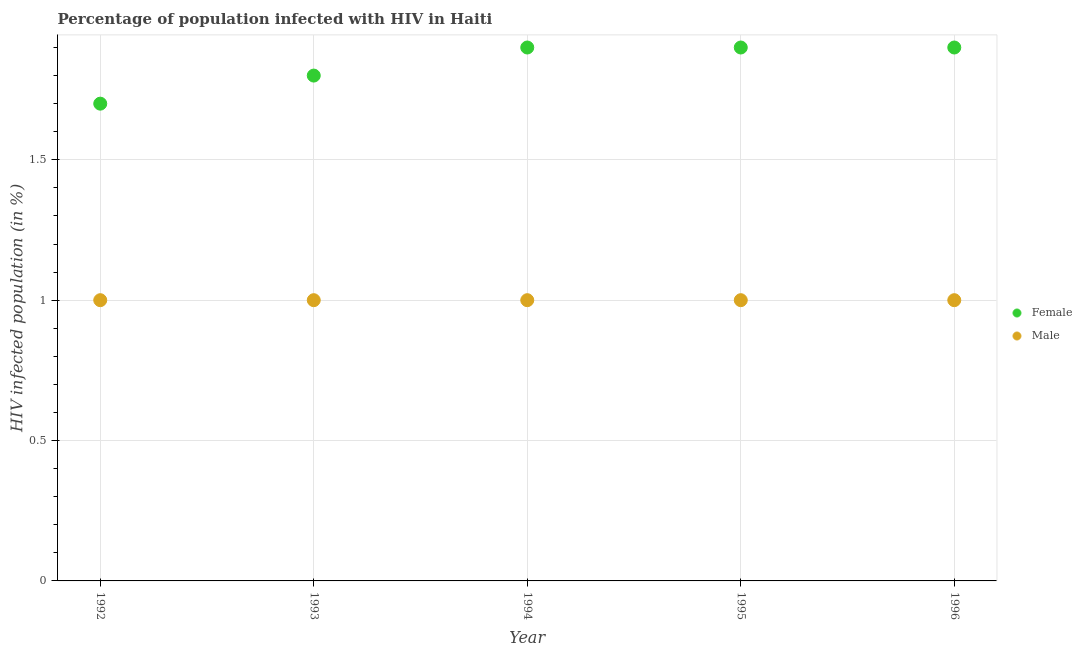What is the percentage of males who are infected with hiv in 1996?
Provide a succinct answer. 1. Across all years, what is the maximum percentage of females who are infected with hiv?
Offer a very short reply. 1.9. Across all years, what is the minimum percentage of males who are infected with hiv?
Your answer should be very brief. 1. In which year was the percentage of males who are infected with hiv minimum?
Ensure brevity in your answer.  1992. What is the total percentage of females who are infected with hiv in the graph?
Keep it short and to the point. 9.2. What is the difference between the percentage of females who are infected with hiv in 1992 and that in 1996?
Provide a succinct answer. -0.2. What is the difference between the percentage of females who are infected with hiv in 1995 and the percentage of males who are infected with hiv in 1992?
Ensure brevity in your answer.  0.9. In the year 1994, what is the difference between the percentage of males who are infected with hiv and percentage of females who are infected with hiv?
Provide a short and direct response. -0.9. In how many years, is the percentage of females who are infected with hiv greater than 1.2 %?
Keep it short and to the point. 5. What is the ratio of the percentage of males who are infected with hiv in 1993 to that in 1994?
Offer a terse response. 1. Is the percentage of males who are infected with hiv in 1994 less than that in 1995?
Keep it short and to the point. No. Is the difference between the percentage of males who are infected with hiv in 1994 and 1996 greater than the difference between the percentage of females who are infected with hiv in 1994 and 1996?
Provide a succinct answer. No. What is the difference between the highest and the lowest percentage of males who are infected with hiv?
Offer a very short reply. 0. In how many years, is the percentage of females who are infected with hiv greater than the average percentage of females who are infected with hiv taken over all years?
Ensure brevity in your answer.  3. Is the percentage of females who are infected with hiv strictly greater than the percentage of males who are infected with hiv over the years?
Provide a short and direct response. Yes. How many years are there in the graph?
Make the answer very short. 5. What is the difference between two consecutive major ticks on the Y-axis?
Make the answer very short. 0.5. Are the values on the major ticks of Y-axis written in scientific E-notation?
Provide a short and direct response. No. How are the legend labels stacked?
Your answer should be very brief. Vertical. What is the title of the graph?
Provide a succinct answer. Percentage of population infected with HIV in Haiti. Does "Investment in Transport" appear as one of the legend labels in the graph?
Your answer should be very brief. No. What is the label or title of the Y-axis?
Offer a terse response. HIV infected population (in %). What is the HIV infected population (in %) of Female in 1992?
Provide a short and direct response. 1.7. What is the HIV infected population (in %) in Male in 1995?
Give a very brief answer. 1. What is the HIV infected population (in %) of Male in 1996?
Provide a short and direct response. 1. Across all years, what is the maximum HIV infected population (in %) in Female?
Provide a short and direct response. 1.9. Across all years, what is the minimum HIV infected population (in %) in Female?
Ensure brevity in your answer.  1.7. What is the total HIV infected population (in %) of Male in the graph?
Give a very brief answer. 5. What is the difference between the HIV infected population (in %) in Male in 1992 and that in 1994?
Give a very brief answer. 0. What is the difference between the HIV infected population (in %) of Female in 1992 and that in 1995?
Give a very brief answer. -0.2. What is the difference between the HIV infected population (in %) in Male in 1992 and that in 1996?
Your answer should be very brief. 0. What is the difference between the HIV infected population (in %) in Male in 1993 and that in 1994?
Your response must be concise. 0. What is the difference between the HIV infected population (in %) of Female in 1993 and that in 1995?
Your response must be concise. -0.1. What is the difference between the HIV infected population (in %) of Female in 1994 and that in 1995?
Provide a short and direct response. 0. What is the difference between the HIV infected population (in %) in Male in 1994 and that in 1995?
Give a very brief answer. 0. What is the difference between the HIV infected population (in %) of Female in 1994 and that in 1996?
Offer a very short reply. 0. What is the difference between the HIV infected population (in %) in Male in 1994 and that in 1996?
Your answer should be compact. 0. What is the difference between the HIV infected population (in %) of Female in 1995 and that in 1996?
Provide a short and direct response. 0. What is the difference between the HIV infected population (in %) of Male in 1995 and that in 1996?
Offer a terse response. 0. What is the difference between the HIV infected population (in %) in Female in 1992 and the HIV infected population (in %) in Male in 1993?
Keep it short and to the point. 0.7. What is the difference between the HIV infected population (in %) in Female in 1992 and the HIV infected population (in %) in Male in 1995?
Your response must be concise. 0.7. What is the difference between the HIV infected population (in %) in Female in 1992 and the HIV infected population (in %) in Male in 1996?
Offer a terse response. 0.7. What is the difference between the HIV infected population (in %) of Female in 1993 and the HIV infected population (in %) of Male in 1995?
Provide a short and direct response. 0.8. What is the difference between the HIV infected population (in %) in Female in 1993 and the HIV infected population (in %) in Male in 1996?
Offer a very short reply. 0.8. What is the difference between the HIV infected population (in %) in Female in 1994 and the HIV infected population (in %) in Male in 1996?
Offer a very short reply. 0.9. What is the average HIV infected population (in %) of Female per year?
Ensure brevity in your answer.  1.84. What is the average HIV infected population (in %) of Male per year?
Make the answer very short. 1. In the year 1992, what is the difference between the HIV infected population (in %) of Female and HIV infected population (in %) of Male?
Provide a succinct answer. 0.7. In the year 1994, what is the difference between the HIV infected population (in %) of Female and HIV infected population (in %) of Male?
Provide a succinct answer. 0.9. In the year 1995, what is the difference between the HIV infected population (in %) of Female and HIV infected population (in %) of Male?
Your response must be concise. 0.9. What is the ratio of the HIV infected population (in %) of Male in 1992 to that in 1993?
Keep it short and to the point. 1. What is the ratio of the HIV infected population (in %) in Female in 1992 to that in 1994?
Make the answer very short. 0.89. What is the ratio of the HIV infected population (in %) in Female in 1992 to that in 1995?
Make the answer very short. 0.89. What is the ratio of the HIV infected population (in %) in Male in 1992 to that in 1995?
Keep it short and to the point. 1. What is the ratio of the HIV infected population (in %) in Female in 1992 to that in 1996?
Your answer should be compact. 0.89. What is the ratio of the HIV infected population (in %) of Male in 1992 to that in 1996?
Your answer should be very brief. 1. What is the ratio of the HIV infected population (in %) of Female in 1993 to that in 1996?
Your answer should be very brief. 0.95. What is the ratio of the HIV infected population (in %) of Male in 1993 to that in 1996?
Ensure brevity in your answer.  1. What is the ratio of the HIV infected population (in %) in Female in 1994 to that in 1996?
Your answer should be very brief. 1. What is the ratio of the HIV infected population (in %) of Male in 1995 to that in 1996?
Offer a very short reply. 1. What is the difference between the highest and the second highest HIV infected population (in %) in Male?
Your answer should be compact. 0. What is the difference between the highest and the lowest HIV infected population (in %) of Female?
Ensure brevity in your answer.  0.2. What is the difference between the highest and the lowest HIV infected population (in %) of Male?
Your answer should be compact. 0. 